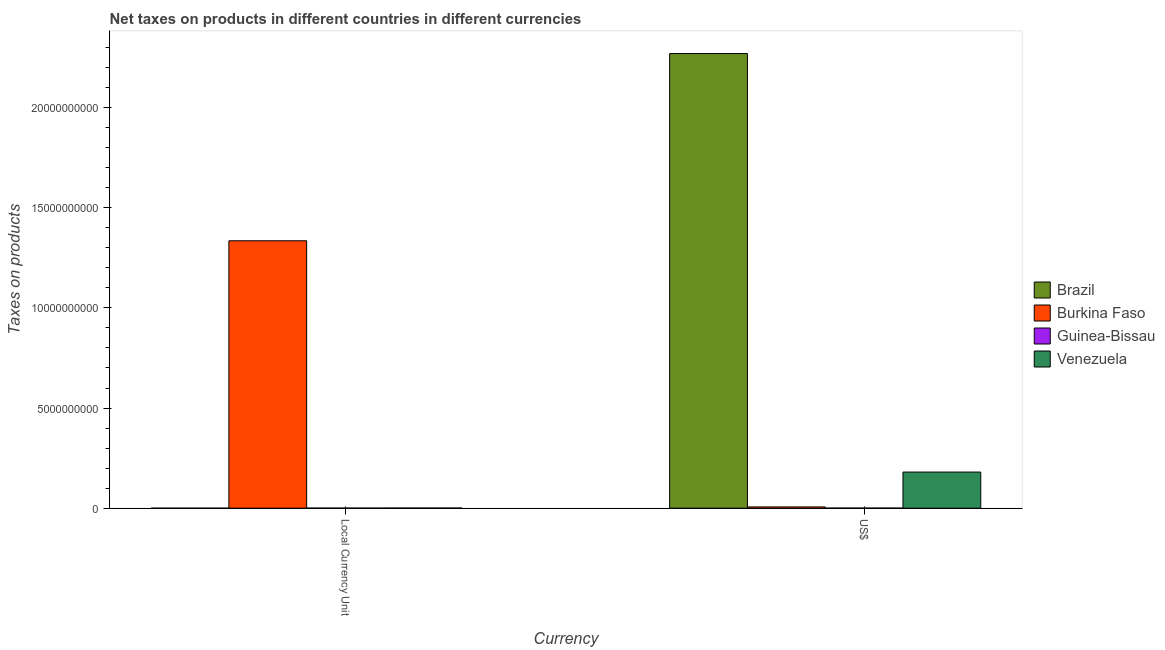How many different coloured bars are there?
Your answer should be very brief. 4. How many bars are there on the 1st tick from the left?
Your response must be concise. 4. How many bars are there on the 1st tick from the right?
Your response must be concise. 4. What is the label of the 1st group of bars from the left?
Provide a succinct answer. Local Currency Unit. What is the net taxes in constant 2005 us$ in Guinea-Bissau?
Your response must be concise. 4.01e+06. Across all countries, what is the maximum net taxes in constant 2005 us$?
Your answer should be very brief. 1.34e+1. Across all countries, what is the minimum net taxes in us$?
Give a very brief answer. 5.23e+06. In which country was the net taxes in us$ maximum?
Provide a short and direct response. Brazil. In which country was the net taxes in constant 2005 us$ minimum?
Give a very brief answer. Brazil. What is the total net taxes in us$ in the graph?
Your answer should be very brief. 2.46e+1. What is the difference between the net taxes in us$ in Burkina Faso and that in Guinea-Bissau?
Make the answer very short. 5.80e+07. What is the difference between the net taxes in constant 2005 us$ in Guinea-Bissau and the net taxes in us$ in Brazil?
Provide a succinct answer. -2.27e+1. What is the average net taxes in us$ per country?
Your response must be concise. 6.14e+09. What is the difference between the net taxes in us$ and net taxes in constant 2005 us$ in Guinea-Bissau?
Your answer should be very brief. 1.22e+06. What is the ratio of the net taxes in constant 2005 us$ in Venezuela to that in Guinea-Bissau?
Offer a terse response. 1.93. In how many countries, is the net taxes in us$ greater than the average net taxes in us$ taken over all countries?
Offer a terse response. 1. What does the 4th bar from the right in Local Currency Unit represents?
Make the answer very short. Brazil. How many bars are there?
Your response must be concise. 8. Are all the bars in the graph horizontal?
Provide a short and direct response. No. Does the graph contain any zero values?
Give a very brief answer. No. Where does the legend appear in the graph?
Ensure brevity in your answer.  Center right. What is the title of the graph?
Offer a very short reply. Net taxes on products in different countries in different currencies. What is the label or title of the X-axis?
Your answer should be very brief. Currency. What is the label or title of the Y-axis?
Make the answer very short. Taxes on products. What is the Taxes on products of Brazil in Local Currency Unit?
Offer a very short reply. 0.43. What is the Taxes on products of Burkina Faso in Local Currency Unit?
Give a very brief answer. 1.34e+1. What is the Taxes on products in Guinea-Bissau in Local Currency Unit?
Offer a terse response. 4.01e+06. What is the Taxes on products of Venezuela in Local Currency Unit?
Provide a short and direct response. 7.74e+06. What is the Taxes on products of Brazil in US$?
Make the answer very short. 2.27e+1. What is the Taxes on products of Burkina Faso in US$?
Provide a succinct answer. 6.32e+07. What is the Taxes on products in Guinea-Bissau in US$?
Your answer should be very brief. 5.23e+06. What is the Taxes on products of Venezuela in US$?
Make the answer very short. 1.80e+09. Across all Currency, what is the maximum Taxes on products in Brazil?
Provide a short and direct response. 2.27e+1. Across all Currency, what is the maximum Taxes on products in Burkina Faso?
Give a very brief answer. 1.34e+1. Across all Currency, what is the maximum Taxes on products in Guinea-Bissau?
Give a very brief answer. 5.23e+06. Across all Currency, what is the maximum Taxes on products of Venezuela?
Offer a very short reply. 1.80e+09. Across all Currency, what is the minimum Taxes on products of Brazil?
Make the answer very short. 0.43. Across all Currency, what is the minimum Taxes on products of Burkina Faso?
Offer a terse response. 6.32e+07. Across all Currency, what is the minimum Taxes on products of Guinea-Bissau?
Give a very brief answer. 4.01e+06. Across all Currency, what is the minimum Taxes on products of Venezuela?
Your response must be concise. 7.74e+06. What is the total Taxes on products of Brazil in the graph?
Offer a terse response. 2.27e+1. What is the total Taxes on products of Burkina Faso in the graph?
Make the answer very short. 1.34e+1. What is the total Taxes on products in Guinea-Bissau in the graph?
Offer a very short reply. 9.24e+06. What is the total Taxes on products of Venezuela in the graph?
Your answer should be compact. 1.81e+09. What is the difference between the Taxes on products in Brazil in Local Currency Unit and that in US$?
Provide a succinct answer. -2.27e+1. What is the difference between the Taxes on products of Burkina Faso in Local Currency Unit and that in US$?
Ensure brevity in your answer.  1.33e+1. What is the difference between the Taxes on products in Guinea-Bissau in Local Currency Unit and that in US$?
Make the answer very short. -1.22e+06. What is the difference between the Taxes on products in Venezuela in Local Currency Unit and that in US$?
Offer a very short reply. -1.80e+09. What is the difference between the Taxes on products in Brazil in Local Currency Unit and the Taxes on products in Burkina Faso in US$?
Make the answer very short. -6.32e+07. What is the difference between the Taxes on products of Brazil in Local Currency Unit and the Taxes on products of Guinea-Bissau in US$?
Your answer should be compact. -5.23e+06. What is the difference between the Taxes on products in Brazil in Local Currency Unit and the Taxes on products in Venezuela in US$?
Make the answer very short. -1.80e+09. What is the difference between the Taxes on products in Burkina Faso in Local Currency Unit and the Taxes on products in Guinea-Bissau in US$?
Keep it short and to the point. 1.33e+1. What is the difference between the Taxes on products in Burkina Faso in Local Currency Unit and the Taxes on products in Venezuela in US$?
Your response must be concise. 1.15e+1. What is the difference between the Taxes on products in Guinea-Bissau in Local Currency Unit and the Taxes on products in Venezuela in US$?
Provide a succinct answer. -1.80e+09. What is the average Taxes on products of Brazil per Currency?
Make the answer very short. 1.13e+1. What is the average Taxes on products in Burkina Faso per Currency?
Your answer should be very brief. 6.71e+09. What is the average Taxes on products in Guinea-Bissau per Currency?
Offer a very short reply. 4.62e+06. What is the average Taxes on products of Venezuela per Currency?
Your response must be concise. 9.06e+08. What is the difference between the Taxes on products of Brazil and Taxes on products of Burkina Faso in Local Currency Unit?
Give a very brief answer. -1.34e+1. What is the difference between the Taxes on products of Brazil and Taxes on products of Guinea-Bissau in Local Currency Unit?
Offer a terse response. -4.01e+06. What is the difference between the Taxes on products in Brazil and Taxes on products in Venezuela in Local Currency Unit?
Ensure brevity in your answer.  -7.74e+06. What is the difference between the Taxes on products of Burkina Faso and Taxes on products of Guinea-Bissau in Local Currency Unit?
Your answer should be compact. 1.33e+1. What is the difference between the Taxes on products of Burkina Faso and Taxes on products of Venezuela in Local Currency Unit?
Give a very brief answer. 1.33e+1. What is the difference between the Taxes on products of Guinea-Bissau and Taxes on products of Venezuela in Local Currency Unit?
Your response must be concise. -3.73e+06. What is the difference between the Taxes on products in Brazil and Taxes on products in Burkina Faso in US$?
Provide a succinct answer. 2.26e+1. What is the difference between the Taxes on products in Brazil and Taxes on products in Guinea-Bissau in US$?
Make the answer very short. 2.27e+1. What is the difference between the Taxes on products of Brazil and Taxes on products of Venezuela in US$?
Provide a short and direct response. 2.09e+1. What is the difference between the Taxes on products of Burkina Faso and Taxes on products of Guinea-Bissau in US$?
Keep it short and to the point. 5.80e+07. What is the difference between the Taxes on products of Burkina Faso and Taxes on products of Venezuela in US$?
Provide a short and direct response. -1.74e+09. What is the difference between the Taxes on products in Guinea-Bissau and Taxes on products in Venezuela in US$?
Your response must be concise. -1.80e+09. What is the ratio of the Taxes on products in Brazil in Local Currency Unit to that in US$?
Keep it short and to the point. 0. What is the ratio of the Taxes on products of Burkina Faso in Local Currency Unit to that in US$?
Your answer should be compact. 211.28. What is the ratio of the Taxes on products of Guinea-Bissau in Local Currency Unit to that in US$?
Keep it short and to the point. 0.77. What is the ratio of the Taxes on products of Venezuela in Local Currency Unit to that in US$?
Your answer should be compact. 0. What is the difference between the highest and the second highest Taxes on products of Brazil?
Your answer should be compact. 2.27e+1. What is the difference between the highest and the second highest Taxes on products of Burkina Faso?
Offer a terse response. 1.33e+1. What is the difference between the highest and the second highest Taxes on products in Guinea-Bissau?
Your answer should be compact. 1.22e+06. What is the difference between the highest and the second highest Taxes on products in Venezuela?
Provide a succinct answer. 1.80e+09. What is the difference between the highest and the lowest Taxes on products in Brazil?
Keep it short and to the point. 2.27e+1. What is the difference between the highest and the lowest Taxes on products of Burkina Faso?
Ensure brevity in your answer.  1.33e+1. What is the difference between the highest and the lowest Taxes on products in Guinea-Bissau?
Offer a very short reply. 1.22e+06. What is the difference between the highest and the lowest Taxes on products of Venezuela?
Provide a short and direct response. 1.80e+09. 